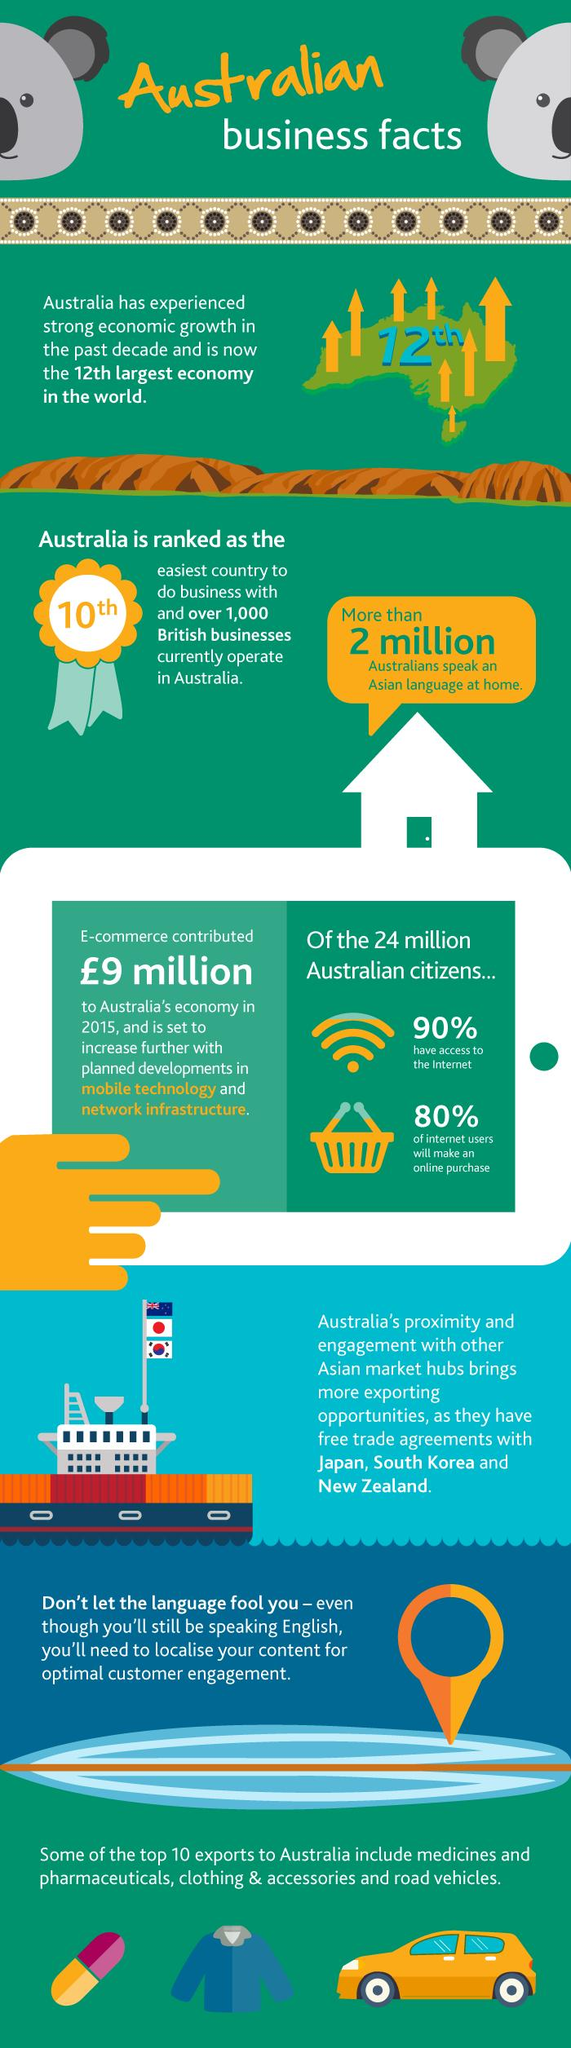Draw attention to some important aspects in this diagram. A significant proportion of Australians, approximately 10%, do not have access to the internet. According to estimates, 80% of internet users in Australia are expected to make an online purchase in the near future. 